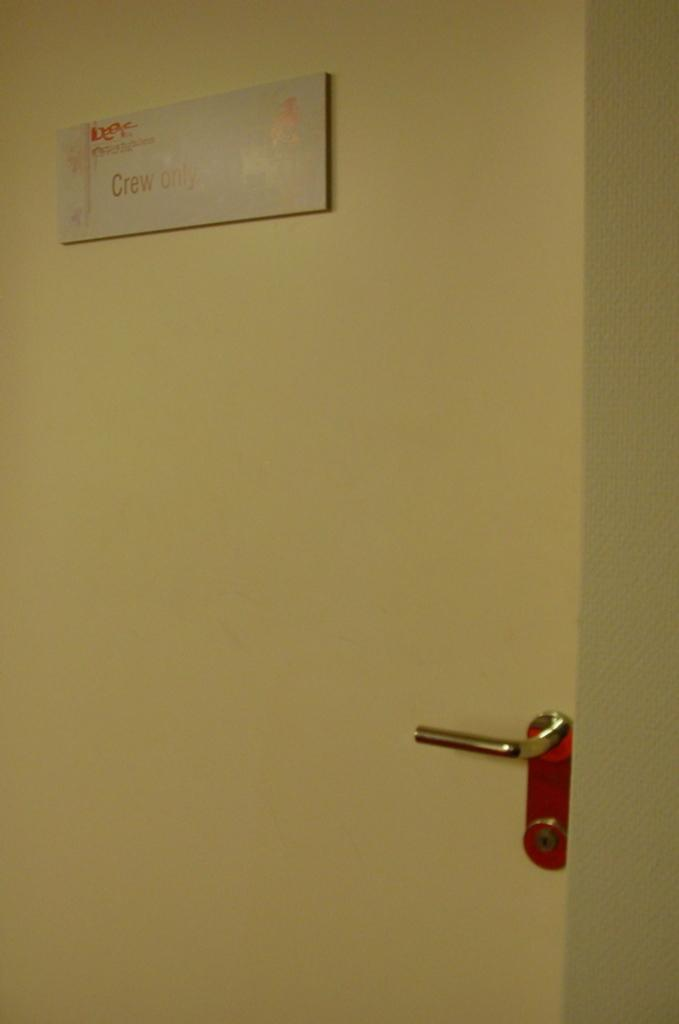What is the main object in the image? There is a door in the image. What is the color of the door? The door is cream in color. Does the door have any specific features? Yes, the door has a handle. What is attached to the door? There is a card pasted on the door. What does the card say? The card has "crew only" written on it. What type of development can be seen happening at the edge of the door in the image? There is no development happening at the edge of the door in the image. 